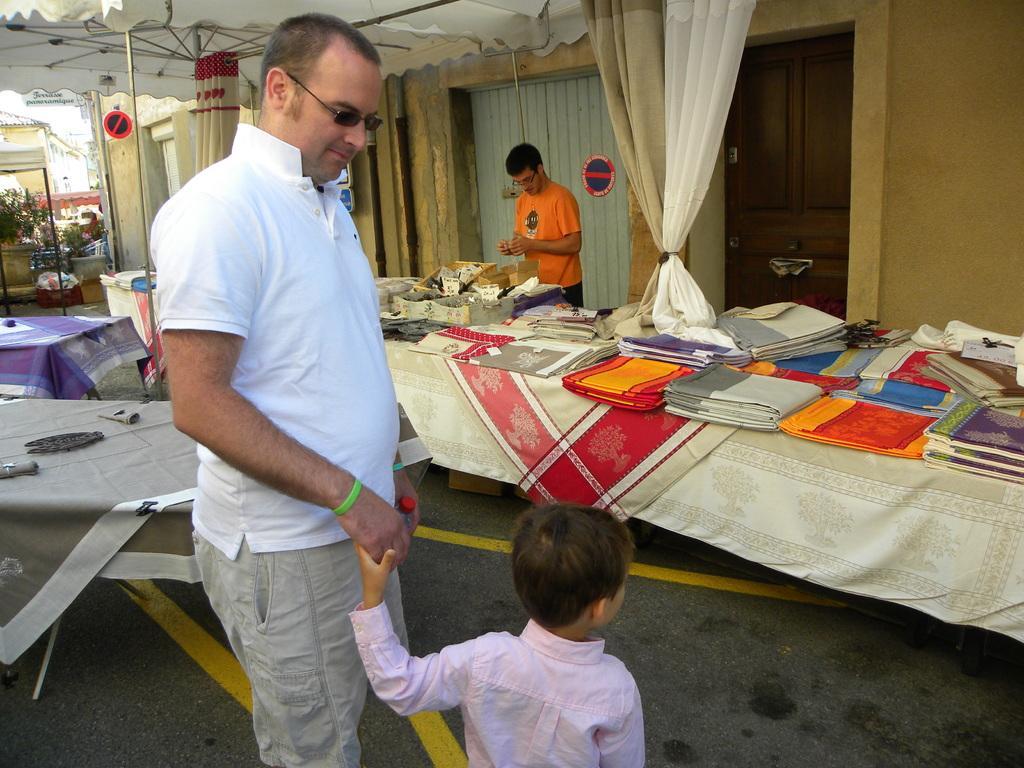Could you give a brief overview of what you see in this image? This picture shows a man and a boy standing and we see few clothes on the table and a man standing 